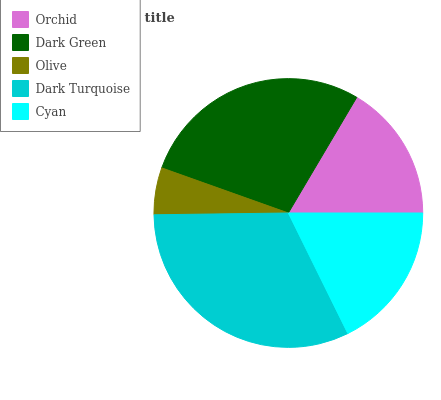Is Olive the minimum?
Answer yes or no. Yes. Is Dark Turquoise the maximum?
Answer yes or no. Yes. Is Dark Green the minimum?
Answer yes or no. No. Is Dark Green the maximum?
Answer yes or no. No. Is Dark Green greater than Orchid?
Answer yes or no. Yes. Is Orchid less than Dark Green?
Answer yes or no. Yes. Is Orchid greater than Dark Green?
Answer yes or no. No. Is Dark Green less than Orchid?
Answer yes or no. No. Is Cyan the high median?
Answer yes or no. Yes. Is Cyan the low median?
Answer yes or no. Yes. Is Orchid the high median?
Answer yes or no. No. Is Orchid the low median?
Answer yes or no. No. 